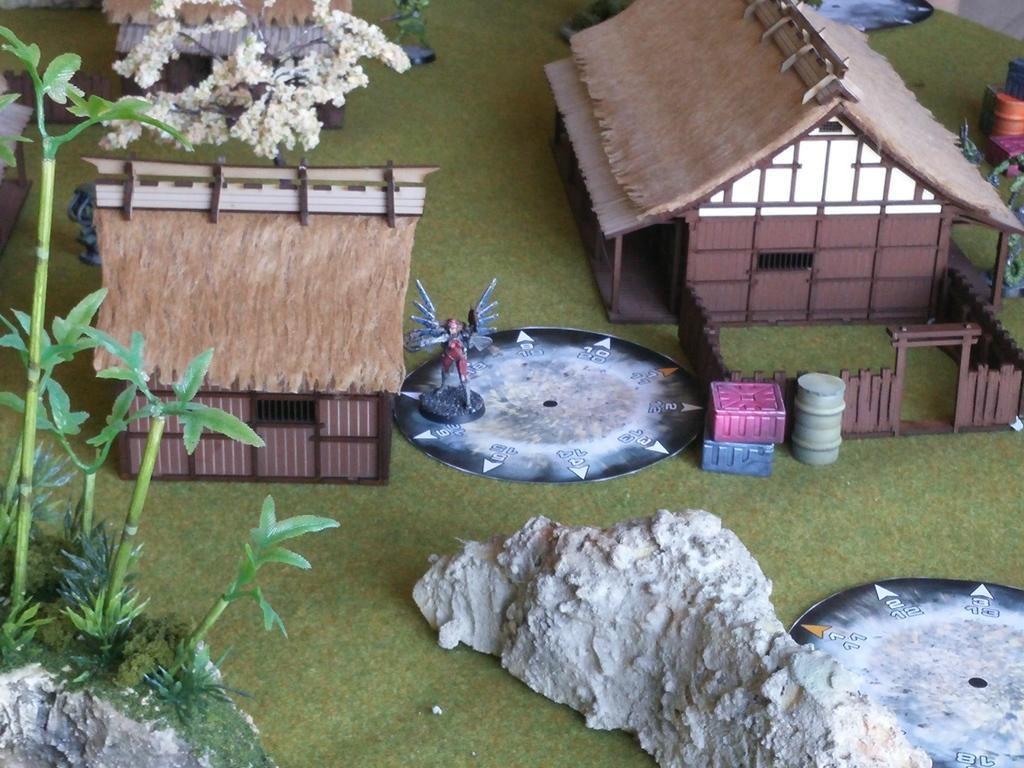Could you give a brief overview of what you see in this image? This picture seems to be containing miniatures. In the foreground we can see the rocks, plants and the green grass. In the center we can see there are some objects placed on the ground and we can see the sculpture of an object and we can see the huts and the fence. In the background we can see the flowers and some other objects are placed on the ground. 